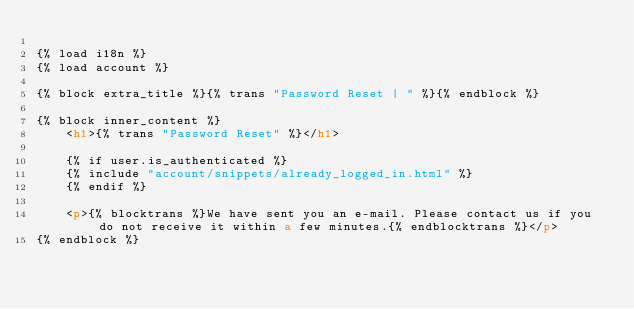Convert code to text. <code><loc_0><loc_0><loc_500><loc_500><_HTML_>
{% load i18n %}
{% load account %}

{% block extra_title %}{% trans "Password Reset | " %}{% endblock %}

{% block inner_content %}
    <h1>{% trans "Password Reset" %}</h1>
    
    {% if user.is_authenticated %}
    {% include "account/snippets/already_logged_in.html" %}
    {% endif %}
    
    <p>{% blocktrans %}We have sent you an e-mail. Please contact us if you do not receive it within a few minutes.{% endblocktrans %}</p>
{% endblock %}
</code> 